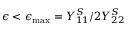<formula> <loc_0><loc_0><loc_500><loc_500>\epsilon < \epsilon _ { \max } = Y _ { 1 1 } ^ { S } / 2 Y _ { 2 2 } ^ { S }</formula> 